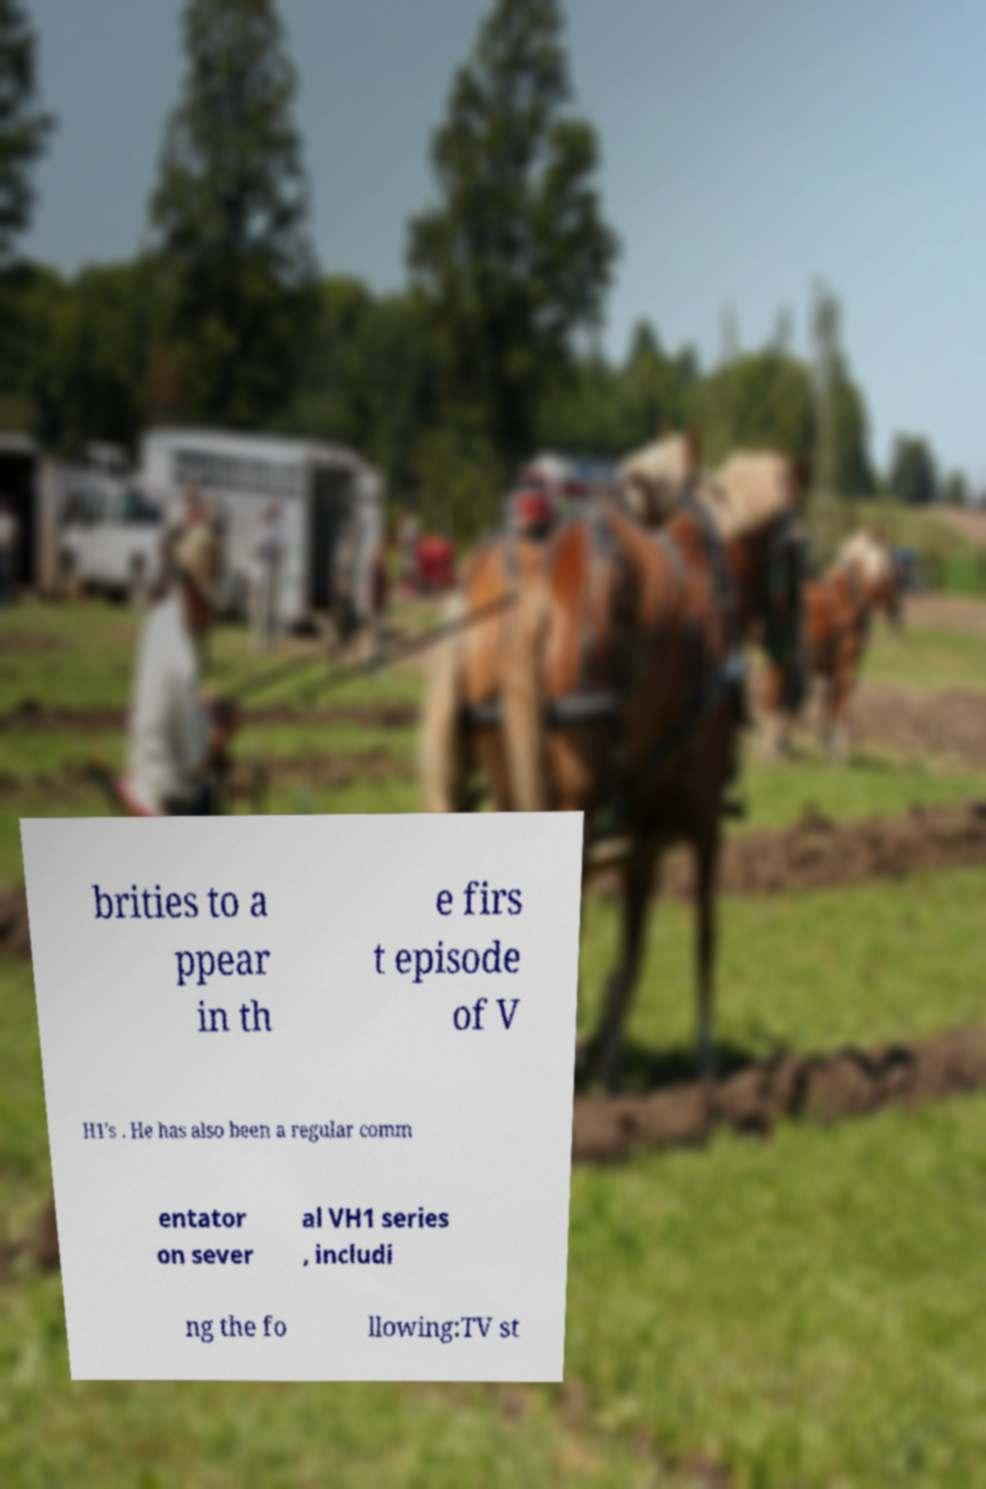What messages or text are displayed in this image? I need them in a readable, typed format. brities to a ppear in th e firs t episode of V H1's . He has also been a regular comm entator on sever al VH1 series , includi ng the fo llowing:TV st 